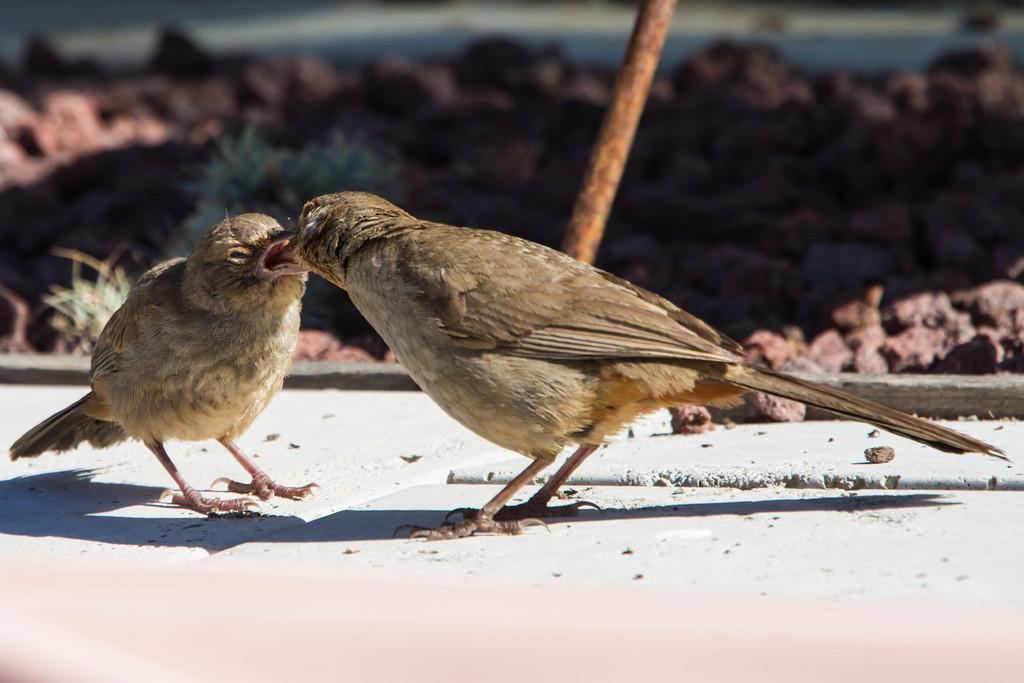How would you summarize this image in a sentence or two? In this picture I can see 2 birds on the white color surface and I see that the birds are of brown color. In the background I can see a brown color thing. 